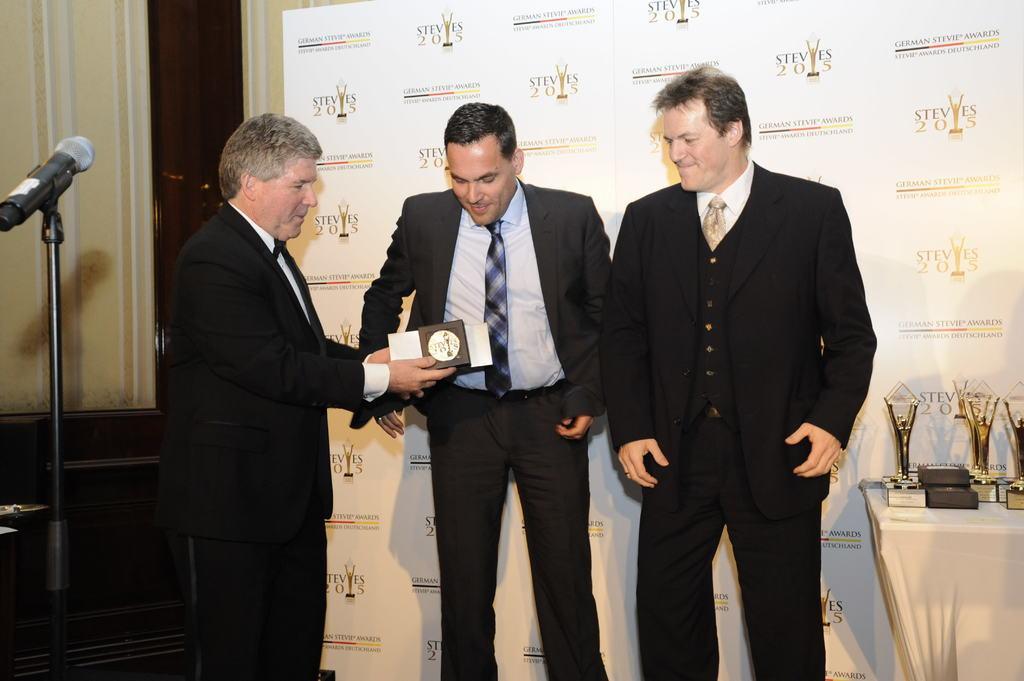Can you describe this image briefly? There are three persons standing. On the left side person is holding something in the hand. Also there is a mic stand with mic. On the right side there is a table with many trophy. In the back there's a wall with something written on that. 